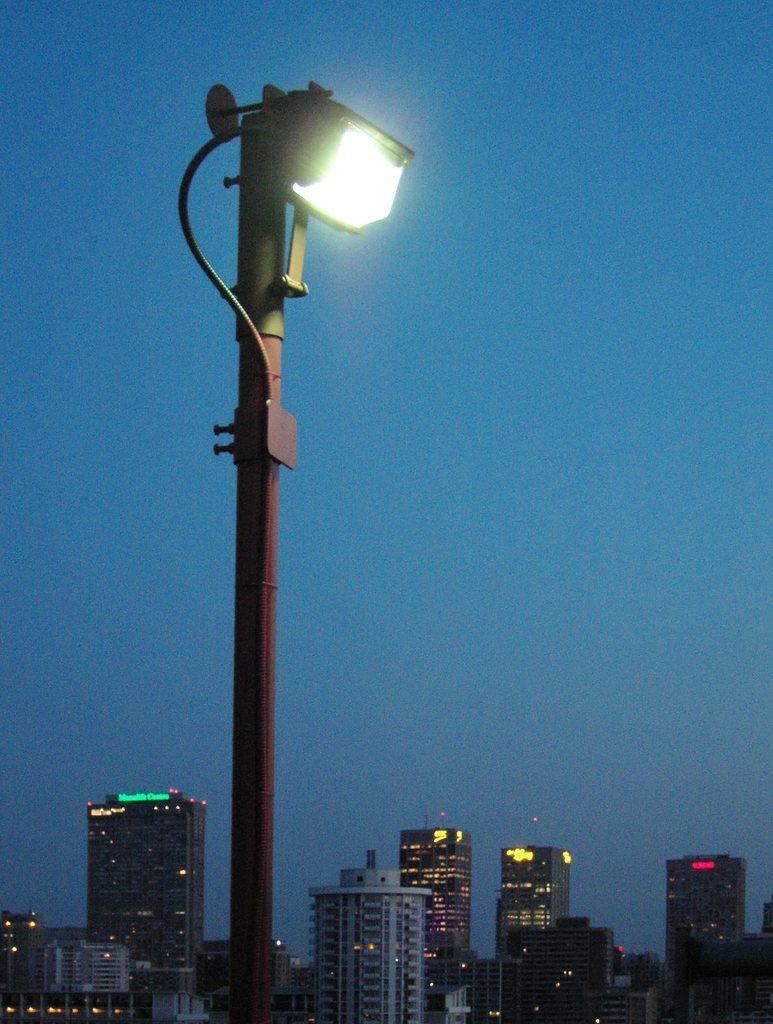Please provide a concise description of this image. In this image we can see there is a street light. In the background there are buildings and sky. 